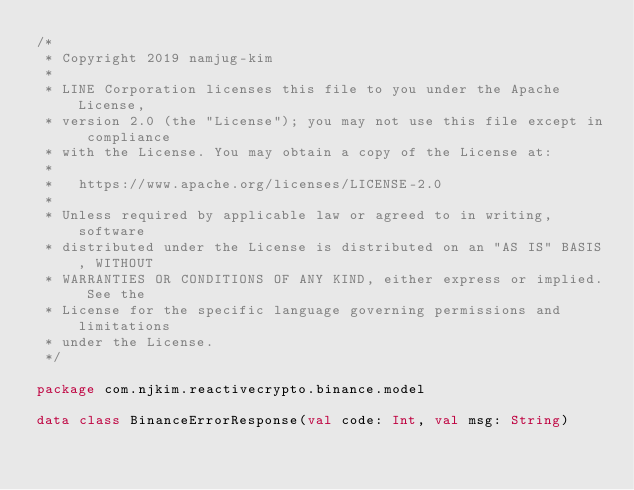Convert code to text. <code><loc_0><loc_0><loc_500><loc_500><_Kotlin_>/*
 * Copyright 2019 namjug-kim
 *
 * LINE Corporation licenses this file to you under the Apache License,
 * version 2.0 (the "License"); you may not use this file except in compliance
 * with the License. You may obtain a copy of the License at:
 *
 *   https://www.apache.org/licenses/LICENSE-2.0
 *
 * Unless required by applicable law or agreed to in writing, software
 * distributed under the License is distributed on an "AS IS" BASIS, WITHOUT
 * WARRANTIES OR CONDITIONS OF ANY KIND, either express or implied. See the
 * License for the specific language governing permissions and limitations
 * under the License.
 */

package com.njkim.reactivecrypto.binance.model

data class BinanceErrorResponse(val code: Int, val msg: String)</code> 